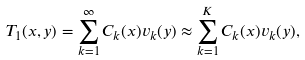Convert formula to latex. <formula><loc_0><loc_0><loc_500><loc_500>T _ { 1 } ( x , y ) = \sum _ { k = 1 } ^ { \infty } C _ { k } ( x ) v _ { k } ( y ) \approx \sum _ { k = 1 } ^ { K } C _ { k } ( x ) v _ { k } ( y ) ,</formula> 